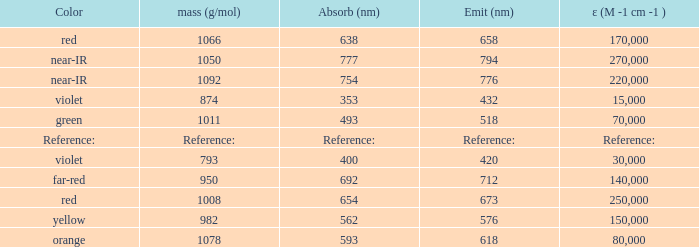Which Emission (in nanometers) has an absorbtion of 593 nm? 618.0. 